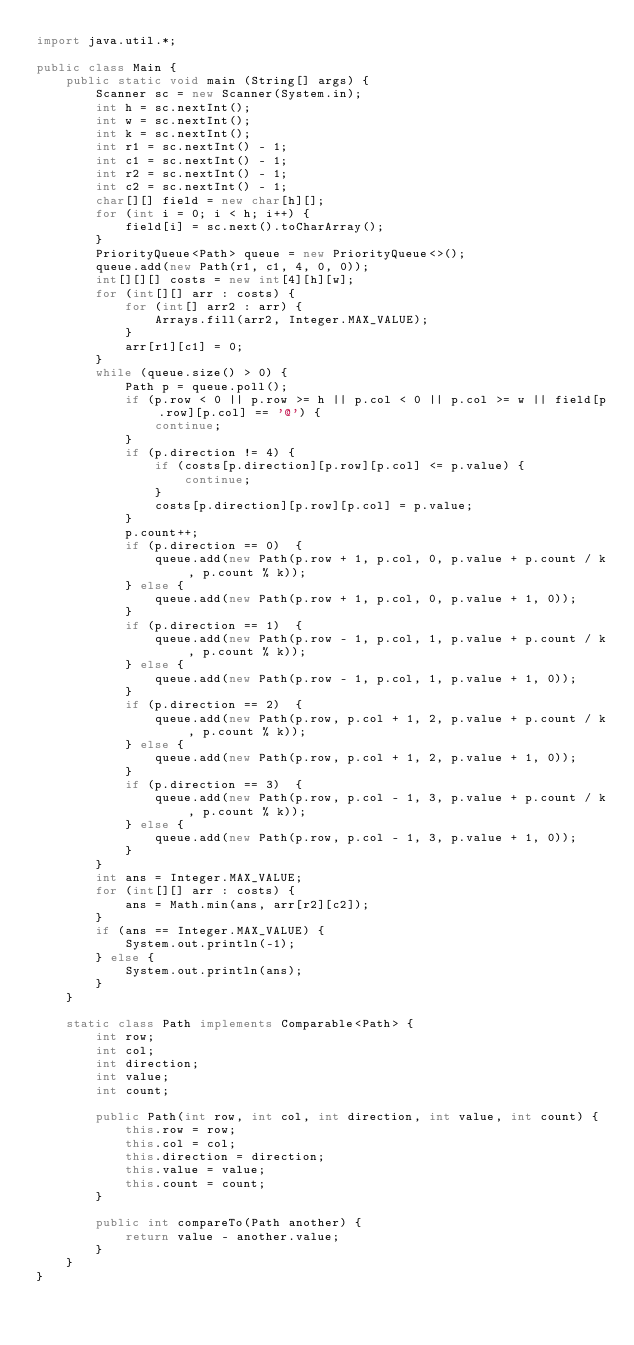Convert code to text. <code><loc_0><loc_0><loc_500><loc_500><_Java_>import java.util.*;

public class Main {
	public static void main (String[] args) {
		Scanner sc = new Scanner(System.in);
		int h = sc.nextInt();
		int w = sc.nextInt();
		int k = sc.nextInt();
		int r1 = sc.nextInt() - 1;
		int c1 = sc.nextInt() - 1;
		int r2 = sc.nextInt() - 1;
		int c2 = sc.nextInt() - 1;
		char[][] field = new char[h][];
		for (int i = 0; i < h; i++) {
		    field[i] = sc.next().toCharArray();
		}
		PriorityQueue<Path> queue = new PriorityQueue<>();
		queue.add(new Path(r1, c1, 4, 0, 0));
		int[][][] costs = new int[4][h][w];
		for (int[][] arr : costs) {
		    for (int[] arr2 : arr) {
		        Arrays.fill(arr2, Integer.MAX_VALUE);
		    }
		    arr[r1][c1] = 0;
		}
		while (queue.size() > 0) {
		    Path p = queue.poll();
		    if (p.row < 0 || p.row >= h || p.col < 0 || p.col >= w || field[p.row][p.col] == '@') {
		        continue;
		    }
		    if (p.direction != 4) {
		        if (costs[p.direction][p.row][p.col] <= p.value) {
		            continue;
		        }
		        costs[p.direction][p.row][p.col] = p.value;
		    }
		    p.count++;
		    if (p.direction == 0)  {
		        queue.add(new Path(p.row + 1, p.col, 0, p.value + p.count / k, p.count % k));
		    } else {
		        queue.add(new Path(p.row + 1, p.col, 0, p.value + 1, 0));
		    }
		    if (p.direction == 1)  {
		        queue.add(new Path(p.row - 1, p.col, 1, p.value + p.count / k, p.count % k));
		    } else {
		        queue.add(new Path(p.row - 1, p.col, 1, p.value + 1, 0));
		    }
		    if (p.direction == 2)  {
		        queue.add(new Path(p.row, p.col + 1, 2, p.value + p.count / k, p.count % k));
		    } else {
		        queue.add(new Path(p.row, p.col + 1, 2, p.value + 1, 0));
		    }
		    if (p.direction == 3)  {
		        queue.add(new Path(p.row, p.col - 1, 3, p.value + p.count / k, p.count % k));
		    } else {
		        queue.add(new Path(p.row, p.col - 1, 3, p.value + 1, 0));
		    }
		}
		int ans = Integer.MAX_VALUE;
		for (int[][] arr : costs) {
		    ans = Math.min(ans, arr[r2][c2]);
		}
		if (ans == Integer.MAX_VALUE) {
		    System.out.println(-1);
		} else {
		    System.out.println(ans);
		}
	}
	
	static class Path implements Comparable<Path> {
	    int row;
	    int col;
	    int direction;
	    int value;
	    int count;
	    
	    public Path(int row, int col, int direction, int value, int count) {
	        this.row = row;
	        this.col = col;
	        this.direction = direction;
	        this.value = value;
	        this.count = count;
	    }
	    
	    public int compareTo(Path another) {
	        return value - another.value;
	    }
	}
}
</code> 